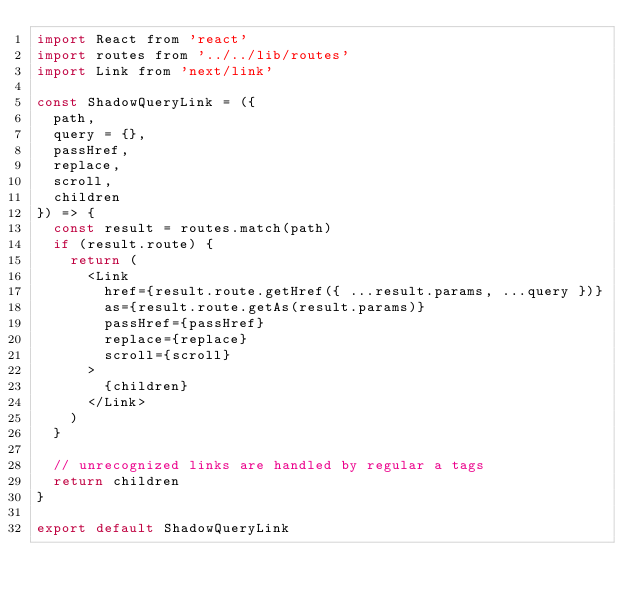Convert code to text. <code><loc_0><loc_0><loc_500><loc_500><_JavaScript_>import React from 'react'
import routes from '../../lib/routes'
import Link from 'next/link'

const ShadowQueryLink = ({
  path,
  query = {},
  passHref,
  replace,
  scroll,
  children
}) => {
  const result = routes.match(path)
  if (result.route) {
    return (
      <Link
        href={result.route.getHref({ ...result.params, ...query })}
        as={result.route.getAs(result.params)}
        passHref={passHref}
        replace={replace}
        scroll={scroll}
      >
        {children}
      </Link>
    )
  }

  // unrecognized links are handled by regular a tags
  return children
}

export default ShadowQueryLink
</code> 